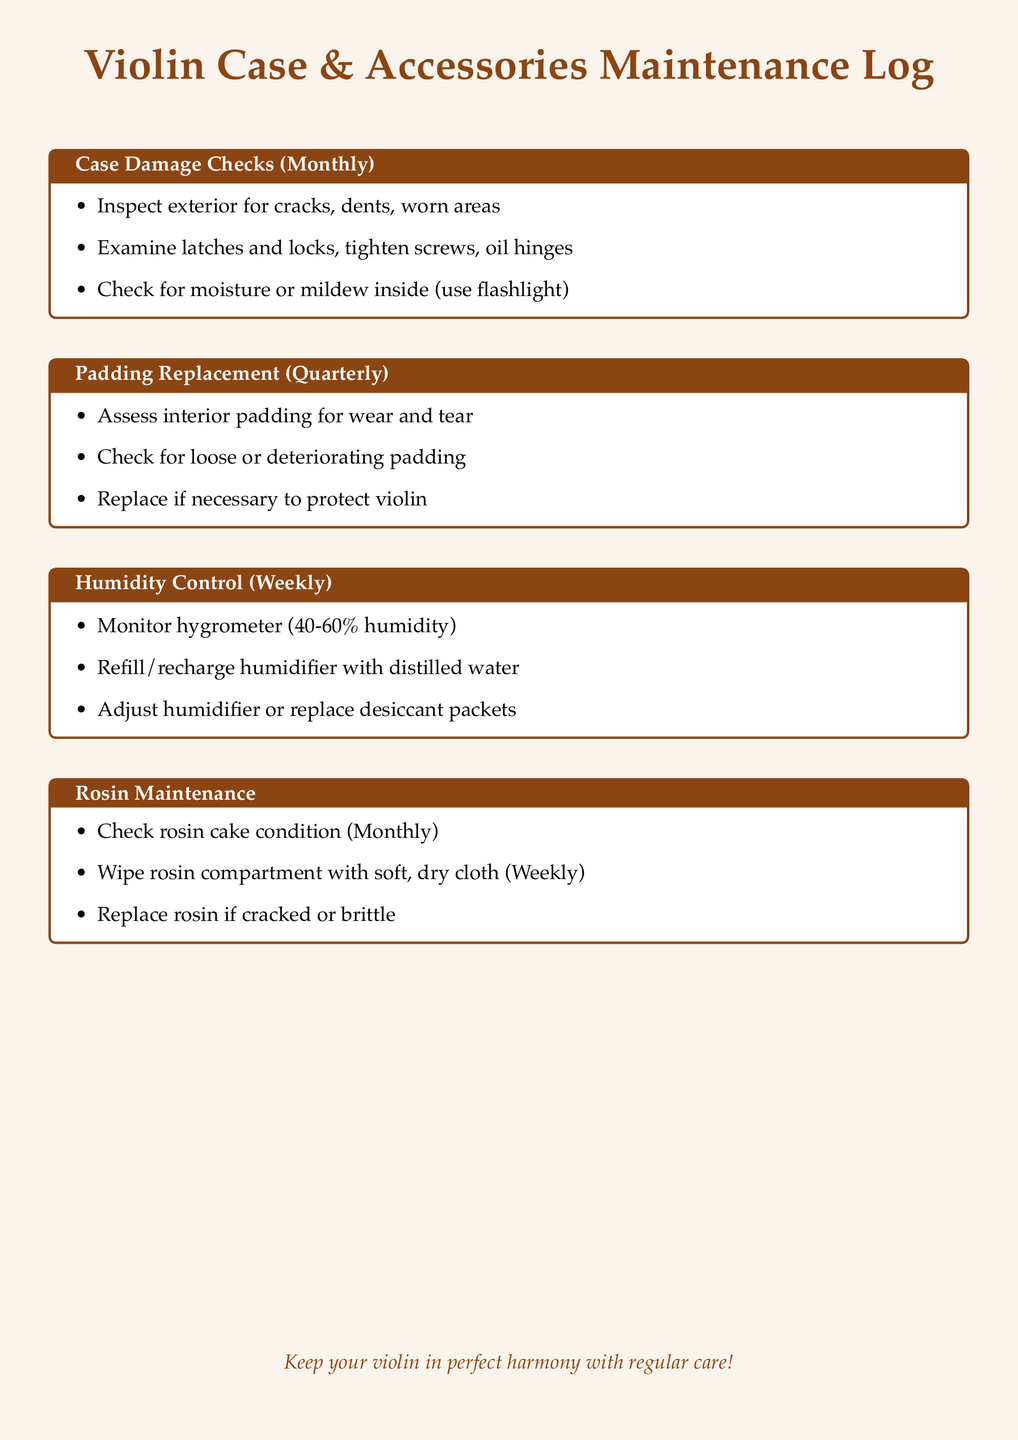What is the frequency for checking case damage? The document specifies that case damage checks should be performed monthly.
Answer: Monthly How often should padding be replaced? According to the maintenance log, padding should be replaced quarterly.
Answer: Quarterly What percentage of humidity should be monitored? The log indicates to maintain humidity between 40-60%.
Answer: 40-60% What is the condition of the rosin checked? The document states that the condition of the rosin cake is checked monthly.
Answer: Monthly What should be done if the rosin is cracked? It advises replacing the rosin if it is cracked or brittle.
Answer: Replace How often should the humidifier be refilled? The log mentions that the humidifier should be refilled weekly with distilled water.
Answer: Weekly What are the latches and locks checked for? The document notes that they should be examined for tightness and to be oiled.
Answer: Tightness What is checked for moisture inside the case? The maintenance log recommends checking for moisture or mildew using a flashlight.
Answer: Flashlight When should the rosin compartment be wiped? The log states that the rosin compartment should be wiped weekly.
Answer: Weekly 